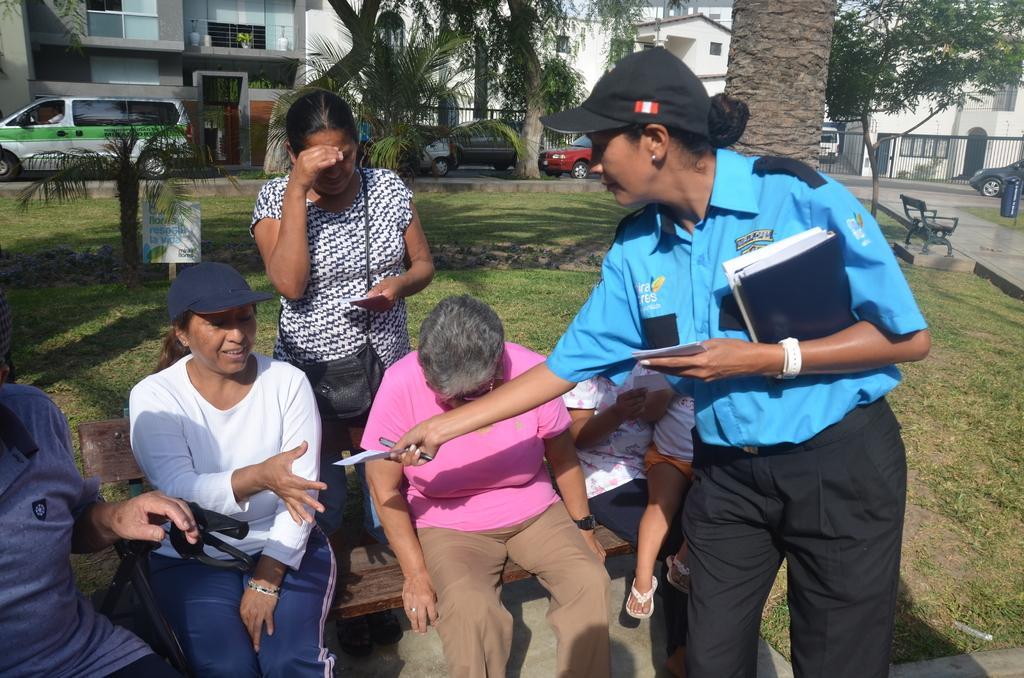In one or two sentences, can you explain what this image depicts? In this image we can see some people sitting on the bench. A woman standing on the right side holding a pen and some books is giving a paper to a lady who is sitting on the bench. On the left side we can see a person sitting on the chair. On the backside we can see a bark of the tree, trees, a building, cars on the road, a house with a roof, fence, grass and the dustbins. 